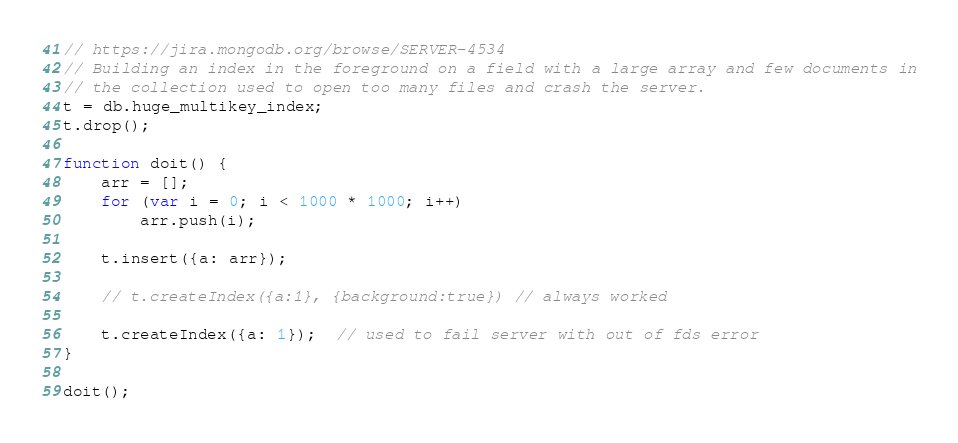<code> <loc_0><loc_0><loc_500><loc_500><_JavaScript_>// https://jira.mongodb.org/browse/SERVER-4534
// Building an index in the foreground on a field with a large array and few documents in
// the collection used to open too many files and crash the server.
t = db.huge_multikey_index;
t.drop();

function doit() {
    arr = [];
    for (var i = 0; i < 1000 * 1000; i++)
        arr.push(i);

    t.insert({a: arr});

    // t.createIndex({a:1}, {background:true}) // always worked

    t.createIndex({a: 1});  // used to fail server with out of fds error
}

doit();
</code> 